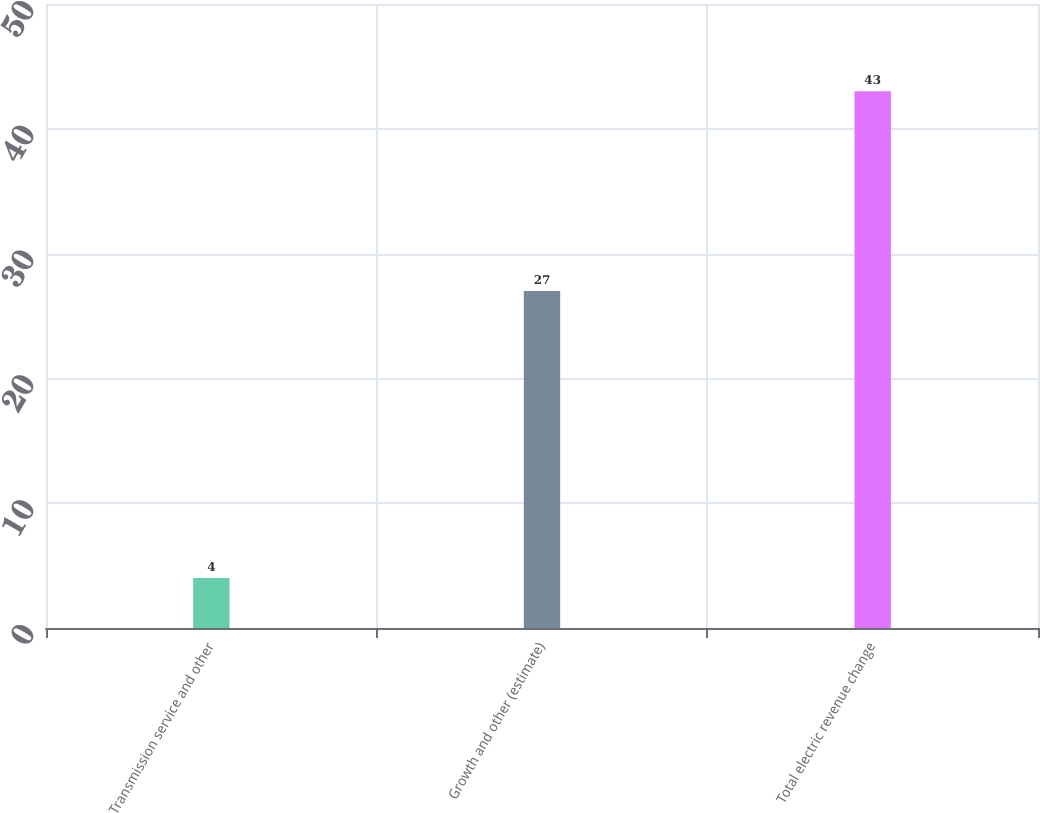<chart> <loc_0><loc_0><loc_500><loc_500><bar_chart><fcel>Transmission service and other<fcel>Growth and other (estimate)<fcel>Total electric revenue change<nl><fcel>4<fcel>27<fcel>43<nl></chart> 